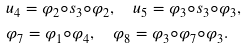<formula> <loc_0><loc_0><loc_500><loc_500>& u _ { 4 } = \varphi _ { 2 } \circ s _ { 3 } \circ \varphi _ { 2 } , \quad u _ { 5 } = \varphi _ { 3 } \circ s _ { 3 } \circ \varphi _ { 3 } , \\ & \varphi _ { 7 } = \varphi _ { 1 } \circ \varphi _ { 4 } , \quad \varphi _ { 8 } = \varphi _ { 3 } \circ \varphi _ { 7 } \circ \varphi _ { 3 } .</formula> 